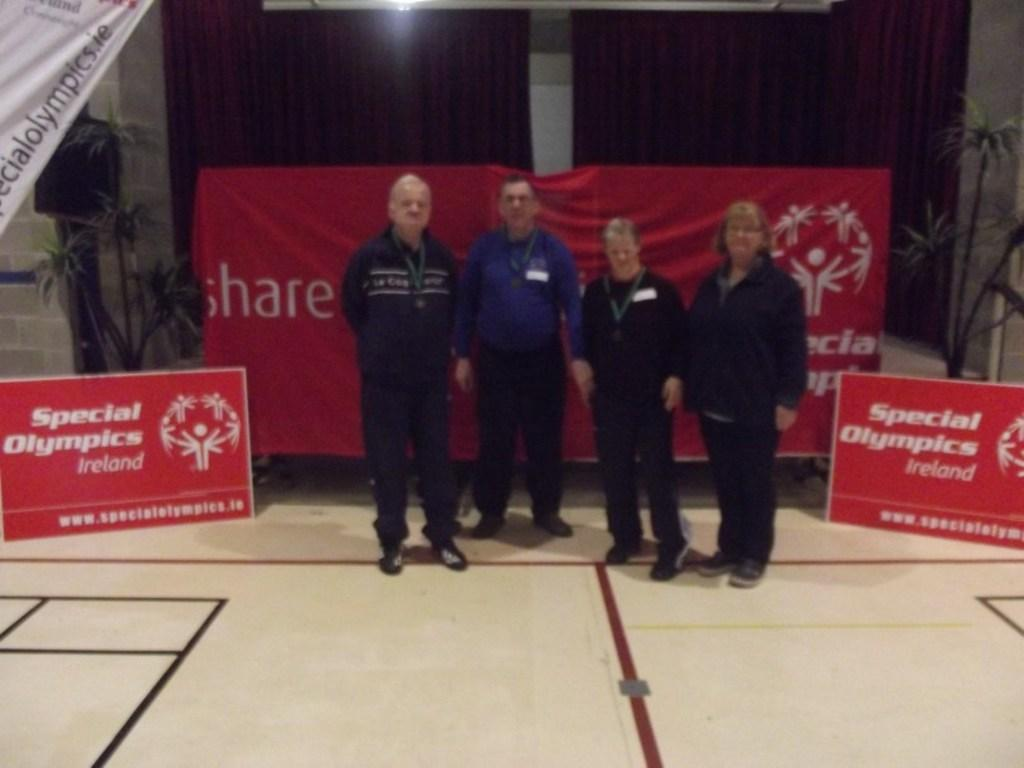How many people are in the image? There is a group of persons standing in the image. What is the surface they are standing on? The persons are standing on the floor. What can be seen hanging in the image? There is a banner in the image. What color is the banner? The banner is red in color. What type of vegetation is present in the image? There is a plant in the image. What source of illumination is visible in the image? There is a light in the image. What type of structure is visible in the image? There is a wall in the image. What type of trade is being conducted in the image? There is no indication of any trade being conducted in the image. What type of property is being discussed in the image? There is no discussion of any property in the image. 